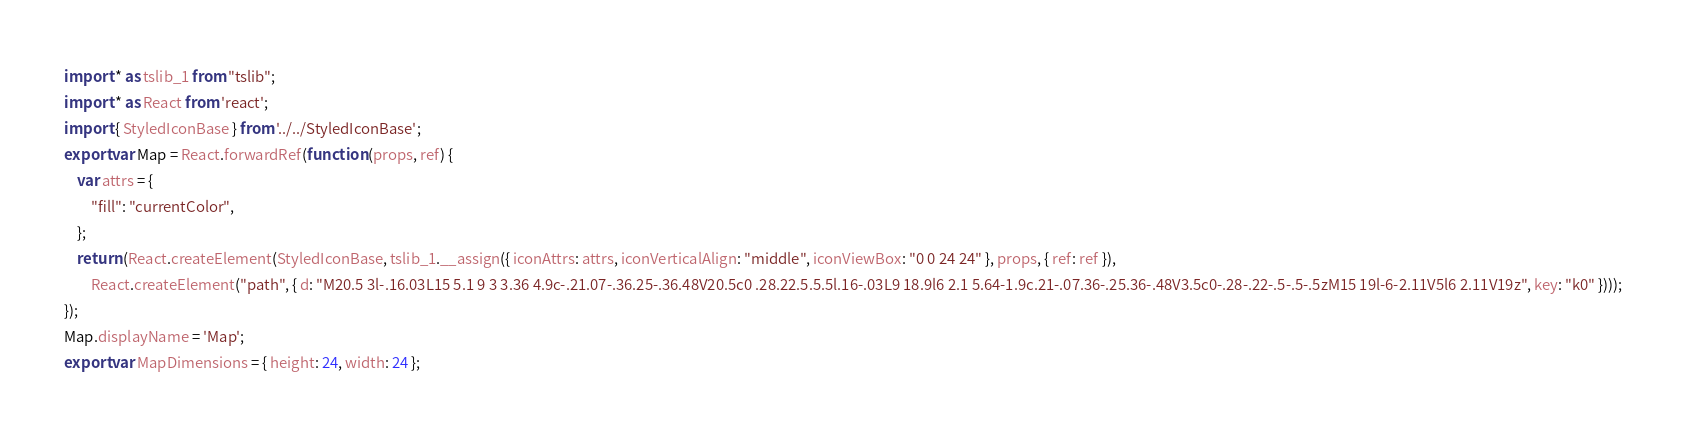Convert code to text. <code><loc_0><loc_0><loc_500><loc_500><_JavaScript_>import * as tslib_1 from "tslib";
import * as React from 'react';
import { StyledIconBase } from '../../StyledIconBase';
export var Map = React.forwardRef(function (props, ref) {
    var attrs = {
        "fill": "currentColor",
    };
    return (React.createElement(StyledIconBase, tslib_1.__assign({ iconAttrs: attrs, iconVerticalAlign: "middle", iconViewBox: "0 0 24 24" }, props, { ref: ref }),
        React.createElement("path", { d: "M20.5 3l-.16.03L15 5.1 9 3 3.36 4.9c-.21.07-.36.25-.36.48V20.5c0 .28.22.5.5.5l.16-.03L9 18.9l6 2.1 5.64-1.9c.21-.07.36-.25.36-.48V3.5c0-.28-.22-.5-.5-.5zM15 19l-6-2.11V5l6 2.11V19z", key: "k0" })));
});
Map.displayName = 'Map';
export var MapDimensions = { height: 24, width: 24 };
</code> 